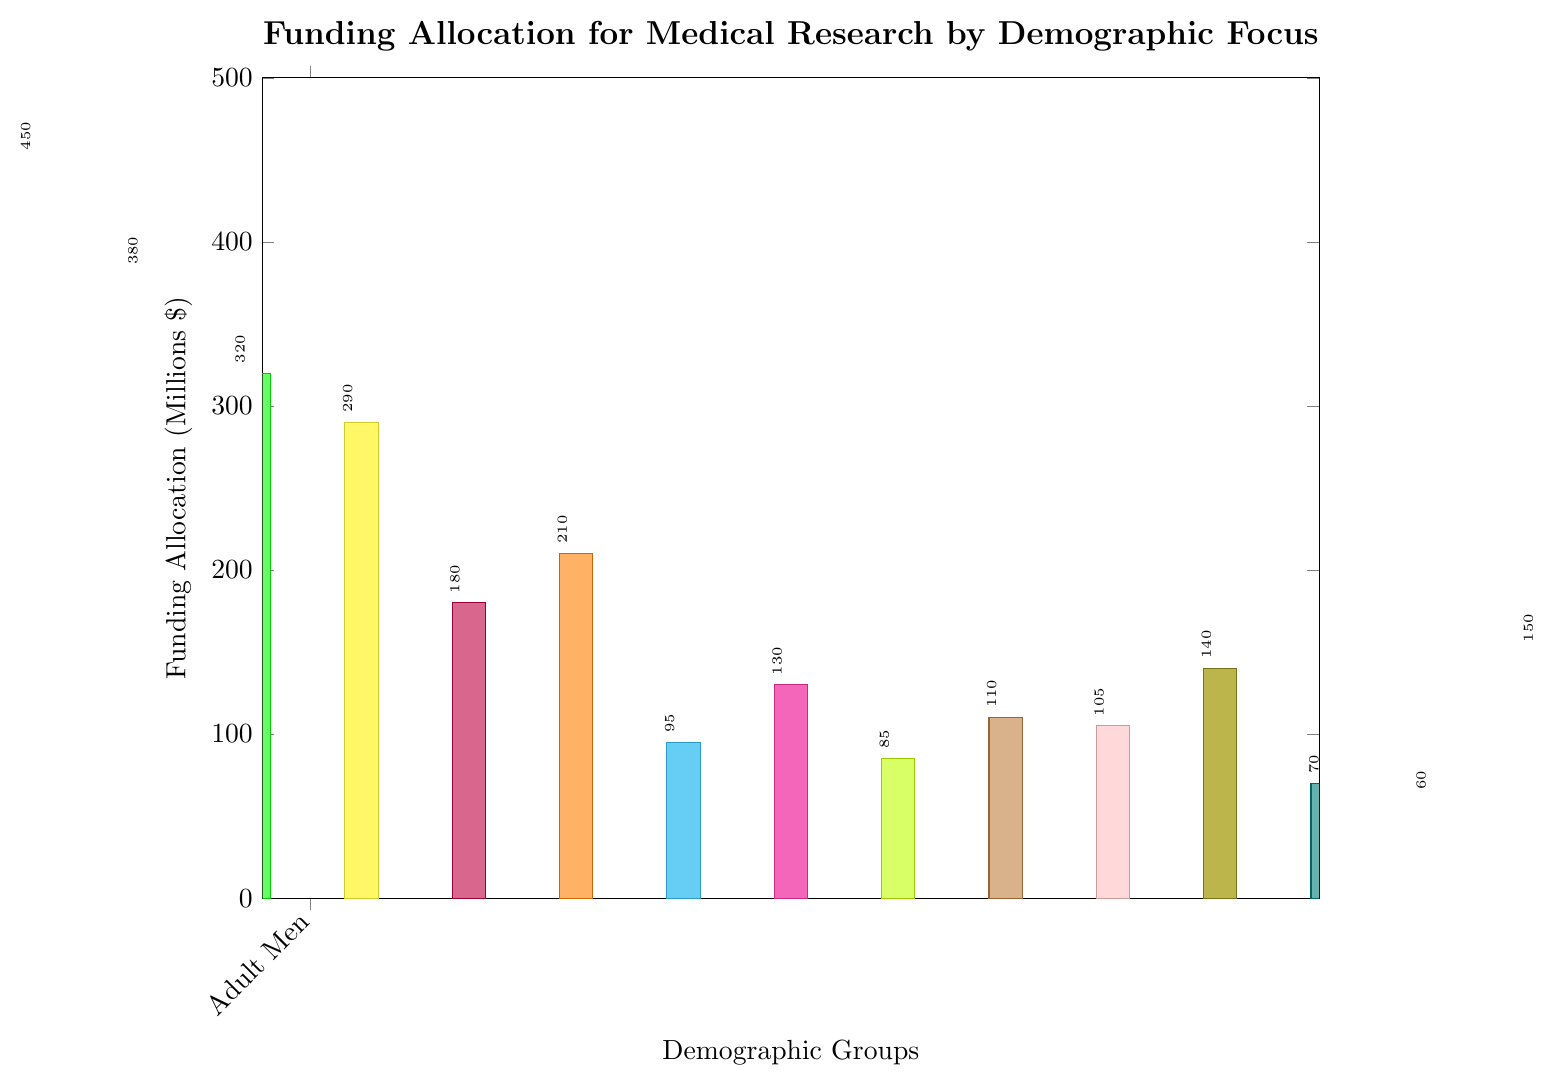what's the total funding allocation for Adult Men and Adult Women? The funding for Adult Men is 450 million dollars and for Adult Women is 380 million dollars. Summing these two amounts gives us 450 + 380 = 830 million dollars.
Answer: 830 million dollars which group has the lowest funding allocation? By looking at the height of the bars, the Immigrants group has the lowest funding allocation, which is 60 million dollars.
Answer: Immigrants how much more funding does the Adults Men group receive than the Adolescents group? The funding for Adult Men is 450 million dollars, and the funding for Adolescents is 150 million dollars. The difference is 450 - 150 = 300 million dollars.
Answer: 300 million dollars what is the average funding allocation for all groups? To find the average, sum up the funding for all demographic groups and divide by the number of groups. Total funding is 450 + 380 + 320 + 290 + 180 + 210 + 95 + 130 + 85 + 110 + 105 + 140 + 70 + 60 + 150 = 2775 million dollars. There are 15 groups, so the average is 2775 / 15 = 185 million dollars.
Answer: 185 million dollars which groups have a funding allocation greater than 300 million dollars? From the bar heights, the groups with more than 300 million dollars in funding are Adult Men and Children.
Answer: Adult Men, Children what is the funding allocation difference between Urban Populations and Rural Populations? The funding for Urban Populations is 110 million dollars and for Rural Populations is 85 million dollars. The difference is 110 - 85 = 25 million dollars.
Answer: 25 million dollars which demographic group receives the highest funding allocation and how much is it? The highest funding allocation goes to Adult Men, which is 450 million dollars.
Answer: Adult Men, 450 million dollars are there any groups with equal funding allocation? By comparing the heights of the bars, there are no groups with exactly equal funding allocation.
Answer: No how does the funding allocation for Racial Minorities compare to that for People with Disabilities? The funding for Racial Minorities is 210 million dollars and for People with Disabilities is 130 million dollars. Racial Minorities receive more funding.
Answer: Racial Minorities receive more what's the combined funding allocation for Pregnant Women, LGBTQ+, and Indigenous Populations? The funding allocations are: Pregnant Women - 180 million dollars, LGBTQ+ - 95 million dollars, and Indigenous Populations - 70 million dollars. The combined funding is 180 + 95 + 70 = 345 million dollars.
Answer: 345 million dollars 